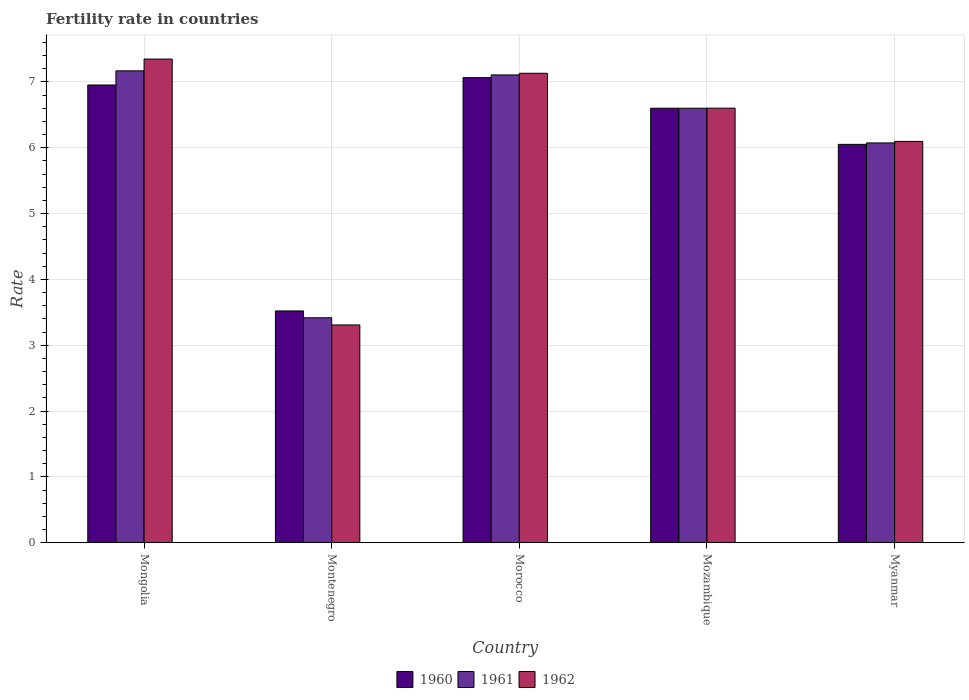Are the number of bars per tick equal to the number of legend labels?
Offer a terse response. Yes. Are the number of bars on each tick of the X-axis equal?
Your answer should be very brief. Yes. How many bars are there on the 3rd tick from the left?
Provide a short and direct response. 3. What is the label of the 4th group of bars from the left?
Provide a short and direct response. Mozambique. What is the fertility rate in 1960 in Morocco?
Your answer should be compact. 7.07. Across all countries, what is the maximum fertility rate in 1960?
Give a very brief answer. 7.07. Across all countries, what is the minimum fertility rate in 1960?
Make the answer very short. 3.52. In which country was the fertility rate in 1962 maximum?
Ensure brevity in your answer.  Mongolia. In which country was the fertility rate in 1962 minimum?
Offer a terse response. Montenegro. What is the total fertility rate in 1962 in the graph?
Offer a terse response. 30.48. What is the difference between the fertility rate in 1960 in Mongolia and that in Myanmar?
Provide a short and direct response. 0.9. What is the difference between the fertility rate in 1962 in Mozambique and the fertility rate in 1960 in Mongolia?
Your response must be concise. -0.35. What is the average fertility rate in 1962 per country?
Ensure brevity in your answer.  6.1. What is the difference between the fertility rate of/in 1962 and fertility rate of/in 1960 in Mongolia?
Your answer should be compact. 0.39. In how many countries, is the fertility rate in 1961 greater than 6?
Provide a succinct answer. 4. What is the ratio of the fertility rate in 1962 in Morocco to that in Myanmar?
Provide a succinct answer. 1.17. Is the difference between the fertility rate in 1962 in Montenegro and Morocco greater than the difference between the fertility rate in 1960 in Montenegro and Morocco?
Provide a succinct answer. No. What is the difference between the highest and the second highest fertility rate in 1960?
Your answer should be very brief. -0.35. What is the difference between the highest and the lowest fertility rate in 1960?
Your answer should be very brief. 3.54. What does the 3rd bar from the right in Mongolia represents?
Make the answer very short. 1960. Is it the case that in every country, the sum of the fertility rate in 1962 and fertility rate in 1960 is greater than the fertility rate in 1961?
Give a very brief answer. Yes. How many countries are there in the graph?
Offer a terse response. 5. Where does the legend appear in the graph?
Offer a terse response. Bottom center. How many legend labels are there?
Make the answer very short. 3. What is the title of the graph?
Give a very brief answer. Fertility rate in countries. Does "1986" appear as one of the legend labels in the graph?
Make the answer very short. No. What is the label or title of the X-axis?
Offer a terse response. Country. What is the label or title of the Y-axis?
Offer a terse response. Rate. What is the Rate of 1960 in Mongolia?
Make the answer very short. 6.95. What is the Rate of 1961 in Mongolia?
Your response must be concise. 7.17. What is the Rate in 1962 in Mongolia?
Your response must be concise. 7.35. What is the Rate in 1960 in Montenegro?
Offer a terse response. 3.52. What is the Rate in 1961 in Montenegro?
Give a very brief answer. 3.42. What is the Rate in 1962 in Montenegro?
Your response must be concise. 3.31. What is the Rate in 1960 in Morocco?
Your answer should be compact. 7.07. What is the Rate of 1961 in Morocco?
Your answer should be compact. 7.11. What is the Rate in 1962 in Morocco?
Your response must be concise. 7.13. What is the Rate of 1962 in Mozambique?
Give a very brief answer. 6.6. What is the Rate of 1960 in Myanmar?
Your answer should be very brief. 6.05. What is the Rate in 1961 in Myanmar?
Offer a very short reply. 6.07. What is the Rate in 1962 in Myanmar?
Keep it short and to the point. 6.1. Across all countries, what is the maximum Rate in 1960?
Keep it short and to the point. 7.07. Across all countries, what is the maximum Rate of 1961?
Your response must be concise. 7.17. Across all countries, what is the maximum Rate in 1962?
Your response must be concise. 7.35. Across all countries, what is the minimum Rate of 1960?
Your response must be concise. 3.52. Across all countries, what is the minimum Rate of 1961?
Ensure brevity in your answer.  3.42. Across all countries, what is the minimum Rate in 1962?
Give a very brief answer. 3.31. What is the total Rate in 1960 in the graph?
Your answer should be compact. 30.19. What is the total Rate of 1961 in the graph?
Your response must be concise. 30.36. What is the total Rate of 1962 in the graph?
Give a very brief answer. 30.48. What is the difference between the Rate of 1960 in Mongolia and that in Montenegro?
Ensure brevity in your answer.  3.43. What is the difference between the Rate of 1961 in Mongolia and that in Montenegro?
Your answer should be very brief. 3.75. What is the difference between the Rate of 1962 in Mongolia and that in Montenegro?
Make the answer very short. 4.04. What is the difference between the Rate of 1960 in Mongolia and that in Morocco?
Offer a terse response. -0.11. What is the difference between the Rate in 1961 in Mongolia and that in Morocco?
Offer a very short reply. 0.06. What is the difference between the Rate of 1962 in Mongolia and that in Morocco?
Offer a very short reply. 0.22. What is the difference between the Rate in 1960 in Mongolia and that in Mozambique?
Make the answer very short. 0.35. What is the difference between the Rate of 1961 in Mongolia and that in Mozambique?
Offer a terse response. 0.57. What is the difference between the Rate of 1962 in Mongolia and that in Mozambique?
Ensure brevity in your answer.  0.75. What is the difference between the Rate of 1960 in Mongolia and that in Myanmar?
Your answer should be compact. 0.9. What is the difference between the Rate in 1961 in Mongolia and that in Myanmar?
Your answer should be compact. 1.09. What is the difference between the Rate in 1962 in Mongolia and that in Myanmar?
Your answer should be very brief. 1.25. What is the difference between the Rate of 1960 in Montenegro and that in Morocco?
Your response must be concise. -3.54. What is the difference between the Rate of 1961 in Montenegro and that in Morocco?
Ensure brevity in your answer.  -3.69. What is the difference between the Rate in 1962 in Montenegro and that in Morocco?
Offer a terse response. -3.82. What is the difference between the Rate of 1960 in Montenegro and that in Mozambique?
Your answer should be very brief. -3.08. What is the difference between the Rate in 1961 in Montenegro and that in Mozambique?
Offer a very short reply. -3.18. What is the difference between the Rate of 1962 in Montenegro and that in Mozambique?
Make the answer very short. -3.29. What is the difference between the Rate of 1960 in Montenegro and that in Myanmar?
Make the answer very short. -2.53. What is the difference between the Rate of 1961 in Montenegro and that in Myanmar?
Your response must be concise. -2.66. What is the difference between the Rate in 1962 in Montenegro and that in Myanmar?
Keep it short and to the point. -2.79. What is the difference between the Rate of 1960 in Morocco and that in Mozambique?
Your answer should be compact. 0.47. What is the difference between the Rate in 1961 in Morocco and that in Mozambique?
Ensure brevity in your answer.  0.51. What is the difference between the Rate in 1962 in Morocco and that in Mozambique?
Your answer should be very brief. 0.53. What is the difference between the Rate in 1960 in Morocco and that in Myanmar?
Your response must be concise. 1.01. What is the difference between the Rate of 1961 in Morocco and that in Myanmar?
Your answer should be compact. 1.03. What is the difference between the Rate of 1962 in Morocco and that in Myanmar?
Offer a terse response. 1.03. What is the difference between the Rate in 1960 in Mozambique and that in Myanmar?
Give a very brief answer. 0.55. What is the difference between the Rate in 1961 in Mozambique and that in Myanmar?
Ensure brevity in your answer.  0.53. What is the difference between the Rate in 1962 in Mozambique and that in Myanmar?
Your answer should be compact. 0.51. What is the difference between the Rate of 1960 in Mongolia and the Rate of 1961 in Montenegro?
Your response must be concise. 3.54. What is the difference between the Rate in 1960 in Mongolia and the Rate in 1962 in Montenegro?
Provide a succinct answer. 3.65. What is the difference between the Rate in 1961 in Mongolia and the Rate in 1962 in Montenegro?
Your answer should be very brief. 3.86. What is the difference between the Rate in 1960 in Mongolia and the Rate in 1961 in Morocco?
Offer a terse response. -0.15. What is the difference between the Rate in 1960 in Mongolia and the Rate in 1962 in Morocco?
Offer a terse response. -0.18. What is the difference between the Rate of 1961 in Mongolia and the Rate of 1962 in Morocco?
Offer a terse response. 0.04. What is the difference between the Rate of 1960 in Mongolia and the Rate of 1961 in Mozambique?
Ensure brevity in your answer.  0.35. What is the difference between the Rate of 1960 in Mongolia and the Rate of 1962 in Mozambique?
Offer a terse response. 0.35. What is the difference between the Rate in 1961 in Mongolia and the Rate in 1962 in Mozambique?
Provide a short and direct response. 0.57. What is the difference between the Rate in 1960 in Mongolia and the Rate in 1962 in Myanmar?
Your response must be concise. 0.86. What is the difference between the Rate in 1961 in Mongolia and the Rate in 1962 in Myanmar?
Give a very brief answer. 1.07. What is the difference between the Rate in 1960 in Montenegro and the Rate in 1961 in Morocco?
Your response must be concise. -3.58. What is the difference between the Rate in 1960 in Montenegro and the Rate in 1962 in Morocco?
Make the answer very short. -3.61. What is the difference between the Rate of 1961 in Montenegro and the Rate of 1962 in Morocco?
Offer a terse response. -3.71. What is the difference between the Rate in 1960 in Montenegro and the Rate in 1961 in Mozambique?
Offer a very short reply. -3.08. What is the difference between the Rate of 1960 in Montenegro and the Rate of 1962 in Mozambique?
Keep it short and to the point. -3.08. What is the difference between the Rate of 1961 in Montenegro and the Rate of 1962 in Mozambique?
Your response must be concise. -3.18. What is the difference between the Rate of 1960 in Montenegro and the Rate of 1961 in Myanmar?
Offer a terse response. -2.55. What is the difference between the Rate of 1960 in Montenegro and the Rate of 1962 in Myanmar?
Give a very brief answer. -2.58. What is the difference between the Rate in 1961 in Montenegro and the Rate in 1962 in Myanmar?
Make the answer very short. -2.68. What is the difference between the Rate in 1960 in Morocco and the Rate in 1961 in Mozambique?
Give a very brief answer. 0.47. What is the difference between the Rate of 1960 in Morocco and the Rate of 1962 in Mozambique?
Ensure brevity in your answer.  0.46. What is the difference between the Rate of 1961 in Morocco and the Rate of 1962 in Mozambique?
Keep it short and to the point. 0.51. What is the difference between the Rate in 1960 in Morocco and the Rate in 1961 in Myanmar?
Offer a very short reply. 0.99. What is the difference between the Rate of 1960 in Morocco and the Rate of 1962 in Myanmar?
Make the answer very short. 0.97. What is the difference between the Rate of 1961 in Morocco and the Rate of 1962 in Myanmar?
Provide a short and direct response. 1.01. What is the difference between the Rate in 1960 in Mozambique and the Rate in 1961 in Myanmar?
Make the answer very short. 0.53. What is the difference between the Rate of 1960 in Mozambique and the Rate of 1962 in Myanmar?
Your answer should be very brief. 0.5. What is the difference between the Rate in 1961 in Mozambique and the Rate in 1962 in Myanmar?
Offer a terse response. 0.5. What is the average Rate in 1960 per country?
Provide a short and direct response. 6.04. What is the average Rate in 1961 per country?
Offer a very short reply. 6.07. What is the average Rate in 1962 per country?
Your answer should be very brief. 6.1. What is the difference between the Rate in 1960 and Rate in 1961 in Mongolia?
Your answer should be very brief. -0.21. What is the difference between the Rate in 1960 and Rate in 1962 in Mongolia?
Offer a very short reply. -0.39. What is the difference between the Rate in 1961 and Rate in 1962 in Mongolia?
Provide a short and direct response. -0.18. What is the difference between the Rate of 1960 and Rate of 1961 in Montenegro?
Provide a short and direct response. 0.1. What is the difference between the Rate in 1960 and Rate in 1962 in Montenegro?
Provide a succinct answer. 0.21. What is the difference between the Rate in 1961 and Rate in 1962 in Montenegro?
Keep it short and to the point. 0.11. What is the difference between the Rate in 1960 and Rate in 1961 in Morocco?
Make the answer very short. -0.04. What is the difference between the Rate in 1960 and Rate in 1962 in Morocco?
Offer a very short reply. -0.07. What is the difference between the Rate in 1961 and Rate in 1962 in Morocco?
Your response must be concise. -0.03. What is the difference between the Rate in 1960 and Rate in 1962 in Mozambique?
Provide a short and direct response. -0. What is the difference between the Rate of 1961 and Rate of 1962 in Mozambique?
Your response must be concise. -0. What is the difference between the Rate in 1960 and Rate in 1961 in Myanmar?
Provide a succinct answer. -0.02. What is the difference between the Rate in 1960 and Rate in 1962 in Myanmar?
Keep it short and to the point. -0.04. What is the difference between the Rate in 1961 and Rate in 1962 in Myanmar?
Offer a very short reply. -0.02. What is the ratio of the Rate of 1960 in Mongolia to that in Montenegro?
Your answer should be very brief. 1.97. What is the ratio of the Rate in 1961 in Mongolia to that in Montenegro?
Provide a succinct answer. 2.1. What is the ratio of the Rate in 1962 in Mongolia to that in Montenegro?
Keep it short and to the point. 2.22. What is the ratio of the Rate of 1960 in Mongolia to that in Morocco?
Provide a succinct answer. 0.98. What is the ratio of the Rate of 1961 in Mongolia to that in Morocco?
Your answer should be compact. 1.01. What is the ratio of the Rate in 1962 in Mongolia to that in Morocco?
Offer a terse response. 1.03. What is the ratio of the Rate of 1960 in Mongolia to that in Mozambique?
Give a very brief answer. 1.05. What is the ratio of the Rate in 1961 in Mongolia to that in Mozambique?
Keep it short and to the point. 1.09. What is the ratio of the Rate of 1962 in Mongolia to that in Mozambique?
Make the answer very short. 1.11. What is the ratio of the Rate in 1960 in Mongolia to that in Myanmar?
Your answer should be very brief. 1.15. What is the ratio of the Rate of 1961 in Mongolia to that in Myanmar?
Your response must be concise. 1.18. What is the ratio of the Rate in 1962 in Mongolia to that in Myanmar?
Offer a terse response. 1.21. What is the ratio of the Rate of 1960 in Montenegro to that in Morocco?
Give a very brief answer. 0.5. What is the ratio of the Rate in 1961 in Montenegro to that in Morocco?
Ensure brevity in your answer.  0.48. What is the ratio of the Rate in 1962 in Montenegro to that in Morocco?
Your answer should be very brief. 0.46. What is the ratio of the Rate of 1960 in Montenegro to that in Mozambique?
Provide a short and direct response. 0.53. What is the ratio of the Rate of 1961 in Montenegro to that in Mozambique?
Give a very brief answer. 0.52. What is the ratio of the Rate of 1962 in Montenegro to that in Mozambique?
Keep it short and to the point. 0.5. What is the ratio of the Rate in 1960 in Montenegro to that in Myanmar?
Provide a short and direct response. 0.58. What is the ratio of the Rate of 1961 in Montenegro to that in Myanmar?
Your answer should be very brief. 0.56. What is the ratio of the Rate in 1962 in Montenegro to that in Myanmar?
Make the answer very short. 0.54. What is the ratio of the Rate of 1960 in Morocco to that in Mozambique?
Ensure brevity in your answer.  1.07. What is the ratio of the Rate in 1961 in Morocco to that in Mozambique?
Keep it short and to the point. 1.08. What is the ratio of the Rate of 1962 in Morocco to that in Mozambique?
Offer a terse response. 1.08. What is the ratio of the Rate in 1960 in Morocco to that in Myanmar?
Provide a short and direct response. 1.17. What is the ratio of the Rate of 1961 in Morocco to that in Myanmar?
Your response must be concise. 1.17. What is the ratio of the Rate in 1962 in Morocco to that in Myanmar?
Offer a very short reply. 1.17. What is the ratio of the Rate in 1960 in Mozambique to that in Myanmar?
Keep it short and to the point. 1.09. What is the ratio of the Rate in 1961 in Mozambique to that in Myanmar?
Give a very brief answer. 1.09. What is the ratio of the Rate in 1962 in Mozambique to that in Myanmar?
Provide a succinct answer. 1.08. What is the difference between the highest and the second highest Rate of 1960?
Offer a terse response. 0.11. What is the difference between the highest and the second highest Rate of 1961?
Provide a succinct answer. 0.06. What is the difference between the highest and the second highest Rate of 1962?
Make the answer very short. 0.22. What is the difference between the highest and the lowest Rate in 1960?
Your response must be concise. 3.54. What is the difference between the highest and the lowest Rate of 1961?
Make the answer very short. 3.75. What is the difference between the highest and the lowest Rate in 1962?
Offer a terse response. 4.04. 